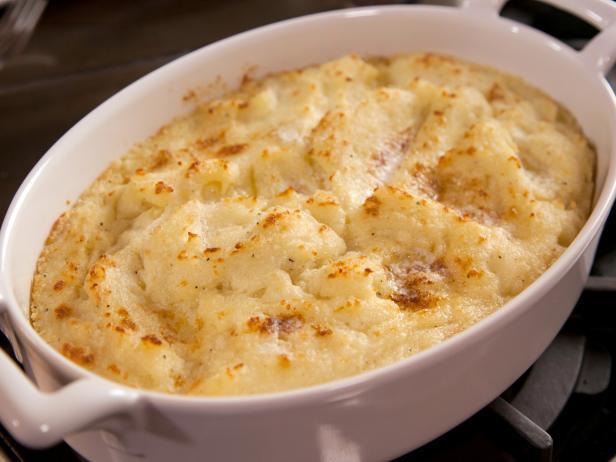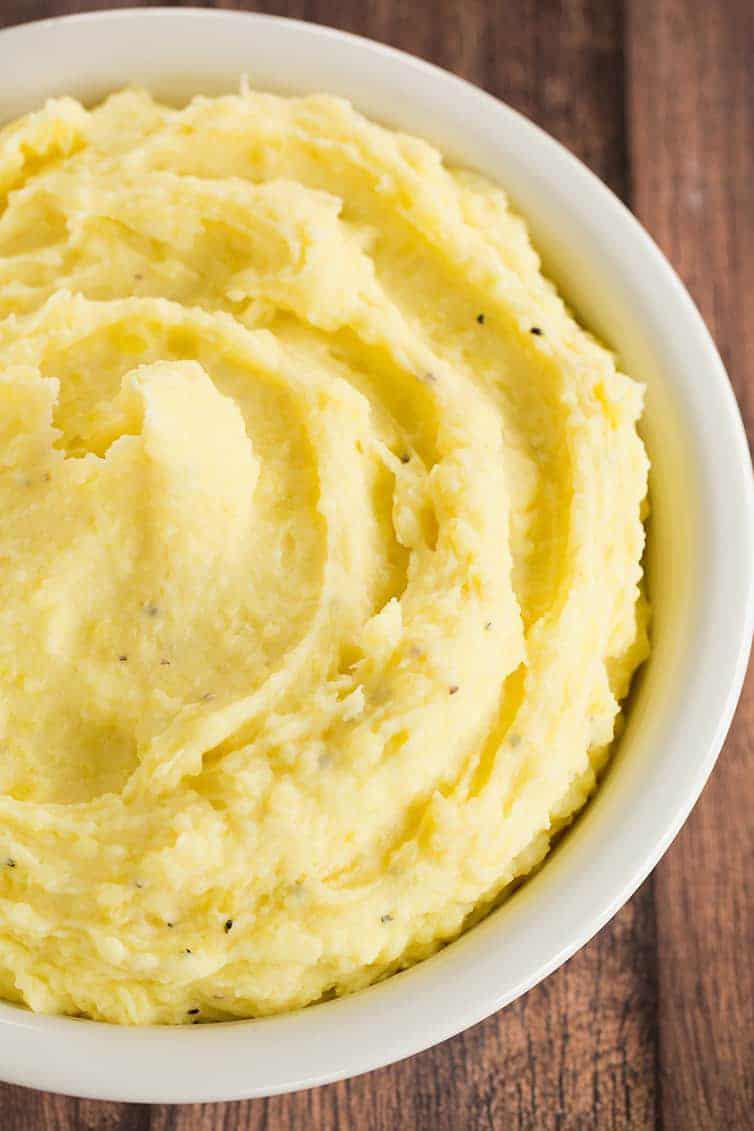The first image is the image on the left, the second image is the image on the right. For the images shown, is this caption "The left image shows mashed potatoes in an oblong white bowl with cut-out handles." true? Answer yes or no. Yes. The first image is the image on the left, the second image is the image on the right. Considering the images on both sides, is "The left and right image contains two round bowls with mash potatoes." valid? Answer yes or no. Yes. 